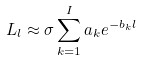<formula> <loc_0><loc_0><loc_500><loc_500>L _ { l } \approx \sigma \sum _ { k = 1 } ^ { I } a _ { k } e ^ { - b _ { k } l }</formula> 